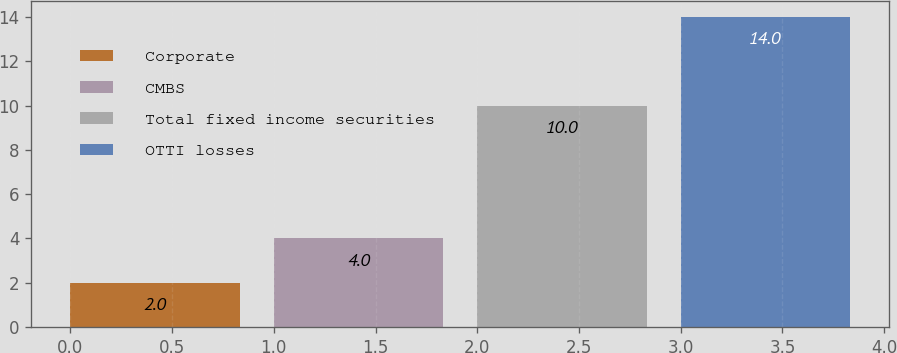Convert chart. <chart><loc_0><loc_0><loc_500><loc_500><bar_chart><fcel>Corporate<fcel>CMBS<fcel>Total fixed income securities<fcel>OTTI losses<nl><fcel>2<fcel>4<fcel>10<fcel>14<nl></chart> 